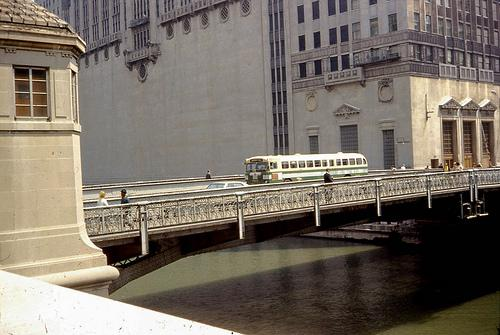Question: what is the color of the water?
Choices:
A. Green.
B. Blue.
C. Gray.
D. Brown.
Answer with the letter. Answer: A Question: what is above the water?
Choices:
A. Boat.
B. Sand.
C. Bridge.
D. Rocks.
Answer with the letter. Answer: C Question: when is the picture taken?
Choices:
A. Night time.
B. Daytime.
C. Evening.
D. Afternoon.
Answer with the letter. Answer: B Question: how many bus?
Choices:
A. 2.
B. 1.
C. 4.
D. 3.
Answer with the letter. Answer: B Question: how is the day?
Choices:
A. Clear.
B. Cloudy.
C. Sunny.
D. Hot.
Answer with the letter. Answer: C 